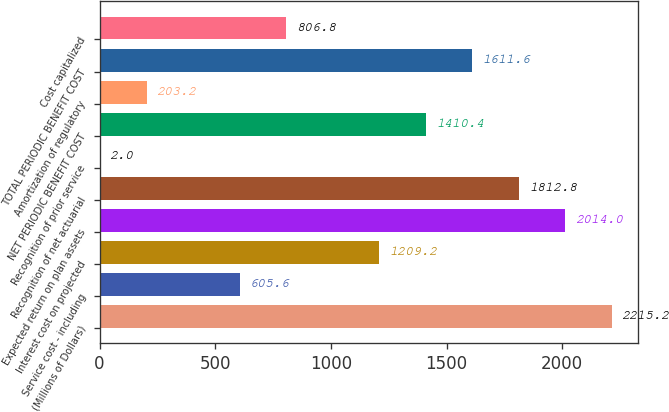<chart> <loc_0><loc_0><loc_500><loc_500><bar_chart><fcel>(Millions of Dollars)<fcel>Service cost - including<fcel>Interest cost on projected<fcel>Expected return on plan assets<fcel>Recognition of net actuarial<fcel>Recognition of prior service<fcel>NET PERIODIC BENEFIT COST<fcel>Amortization of regulatory<fcel>TOTAL PERIODIC BENEFIT COST<fcel>Cost capitalized<nl><fcel>2215.2<fcel>605.6<fcel>1209.2<fcel>2014<fcel>1812.8<fcel>2<fcel>1410.4<fcel>203.2<fcel>1611.6<fcel>806.8<nl></chart> 